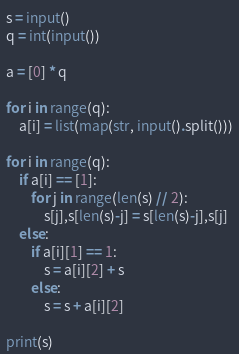<code> <loc_0><loc_0><loc_500><loc_500><_Python_>s = input()
q = int(input())

a = [0] * q

for i in range(q):
    a[i] = list(map(str, input().split()))
    
for i in range(q):
    if a[i] == [1]:
        for j in range(len(s) // 2):
            s[j],s[len(s)-j] = s[len(s)-j],s[j]
    else:
        if a[i][1] == 1:
            s = a[i][2] + s
        else:
            s = s + a[i][2]
            
print(s)</code> 